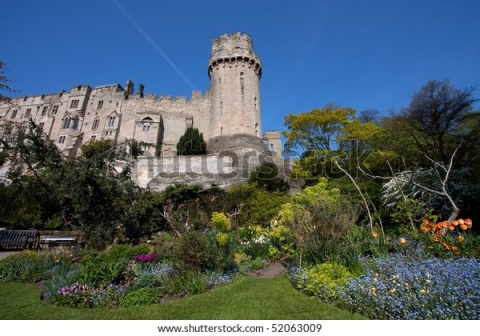If you were to write a fantasy story set in this castle, what would the plot be? In a realm of magic and mystery, this majestic castle was once the seat of an ancient and powerful kingdom. The plot revolves around a young, orphaned peasant named Elara who discovers she is the last descendant of an ancient line of sorcerers. Drawn to the castle by a mystical force, she uncovers hidden passages, forgotten spells, and ancient relics that once belonged to her ancestors.

As Elara delves deeper into the secrets of the castle, she learns of a dark prophecy foretelling the return of a malevolent sorcerer who was imprisoned within the castle walls centuries ago. With the help of a ragtag group of friends, including a rogue knight, a wise old gardener, and a mischievous fairy, Elara embarks on a quest to unlock her latent powers and prevent the sorcerer's return.

The story is filled with adventure, magic, and intrigue as Elara faces numerous challenges, from deciphering cryptic runes in the castle's dungeon to battling enchanted creatures guarding the sorcerer's prison. Throughout her journey, Elara discovers the true strength within herself and the power of friendship, ultimately transforming from a humble peasant into a legendary sorceress who saves her kingdom. 